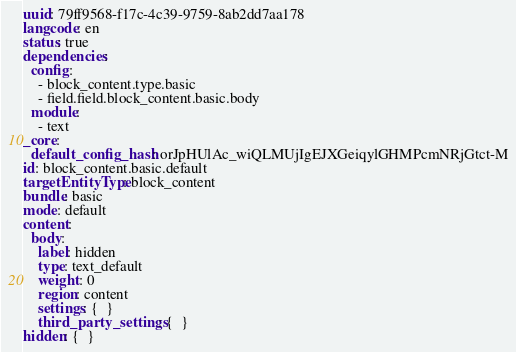Convert code to text. <code><loc_0><loc_0><loc_500><loc_500><_YAML_>uuid: 79ff9568-f17c-4c39-9759-8ab2dd7aa178
langcode: en
status: true
dependencies:
  config:
    - block_content.type.basic
    - field.field.block_content.basic.body
  module:
    - text
_core:
  default_config_hash: orJpHUlAc_wiQLMUjIgEJXGeiqylGHMPcmNRjGtct-M
id: block_content.basic.default
targetEntityType: block_content
bundle: basic
mode: default
content:
  body:
    label: hidden
    type: text_default
    weight: 0
    region: content
    settings: {  }
    third_party_settings: {  }
hidden: {  }
</code> 